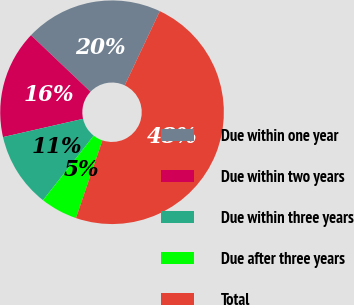Convert chart. <chart><loc_0><loc_0><loc_500><loc_500><pie_chart><fcel>Due within one year<fcel>Due within two years<fcel>Due within three years<fcel>Due after three years<fcel>Total<nl><fcel>19.94%<fcel>15.66%<fcel>10.84%<fcel>5.37%<fcel>48.19%<nl></chart> 